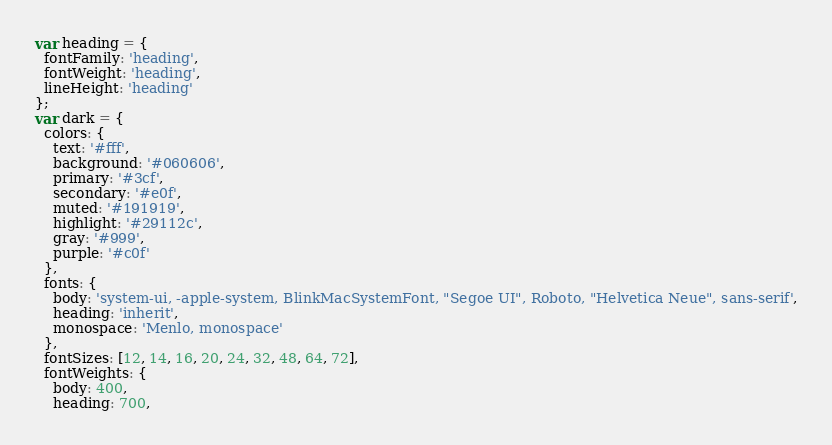Convert code to text. <code><loc_0><loc_0><loc_500><loc_500><_JavaScript_>var heading = {
  fontFamily: 'heading',
  fontWeight: 'heading',
  lineHeight: 'heading'
};
var dark = {
  colors: {
    text: '#fff',
    background: '#060606',
    primary: '#3cf',
    secondary: '#e0f',
    muted: '#191919',
    highlight: '#29112c',
    gray: '#999',
    purple: '#c0f'
  },
  fonts: {
    body: 'system-ui, -apple-system, BlinkMacSystemFont, "Segoe UI", Roboto, "Helvetica Neue", sans-serif',
    heading: 'inherit',
    monospace: 'Menlo, monospace'
  },
  fontSizes: [12, 14, 16, 20, 24, 32, 48, 64, 72],
  fontWeights: {
    body: 400,
    heading: 700,</code> 